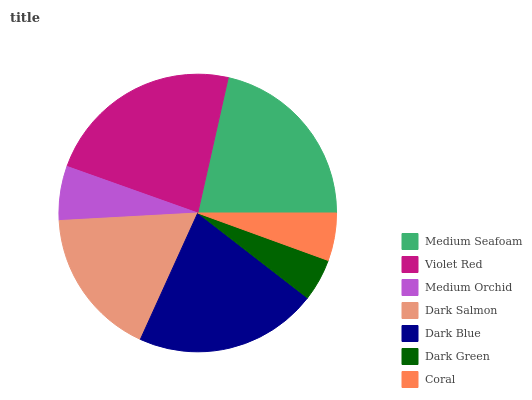Is Dark Green the minimum?
Answer yes or no. Yes. Is Violet Red the maximum?
Answer yes or no. Yes. Is Medium Orchid the minimum?
Answer yes or no. No. Is Medium Orchid the maximum?
Answer yes or no. No. Is Violet Red greater than Medium Orchid?
Answer yes or no. Yes. Is Medium Orchid less than Violet Red?
Answer yes or no. Yes. Is Medium Orchid greater than Violet Red?
Answer yes or no. No. Is Violet Red less than Medium Orchid?
Answer yes or no. No. Is Dark Salmon the high median?
Answer yes or no. Yes. Is Dark Salmon the low median?
Answer yes or no. Yes. Is Violet Red the high median?
Answer yes or no. No. Is Violet Red the low median?
Answer yes or no. No. 